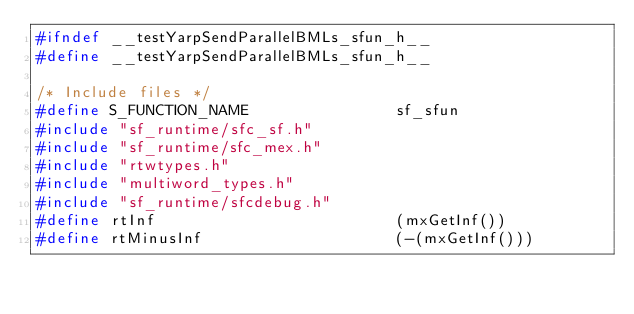<code> <loc_0><loc_0><loc_500><loc_500><_C_>#ifndef __testYarpSendParallelBMLs_sfun_h__
#define __testYarpSendParallelBMLs_sfun_h__

/* Include files */
#define S_FUNCTION_NAME                sf_sfun
#include "sf_runtime/sfc_sf.h"
#include "sf_runtime/sfc_mex.h"
#include "rtwtypes.h"
#include "multiword_types.h"
#include "sf_runtime/sfcdebug.h"
#define rtInf                          (mxGetInf())
#define rtMinusInf                     (-(mxGetInf()))</code> 